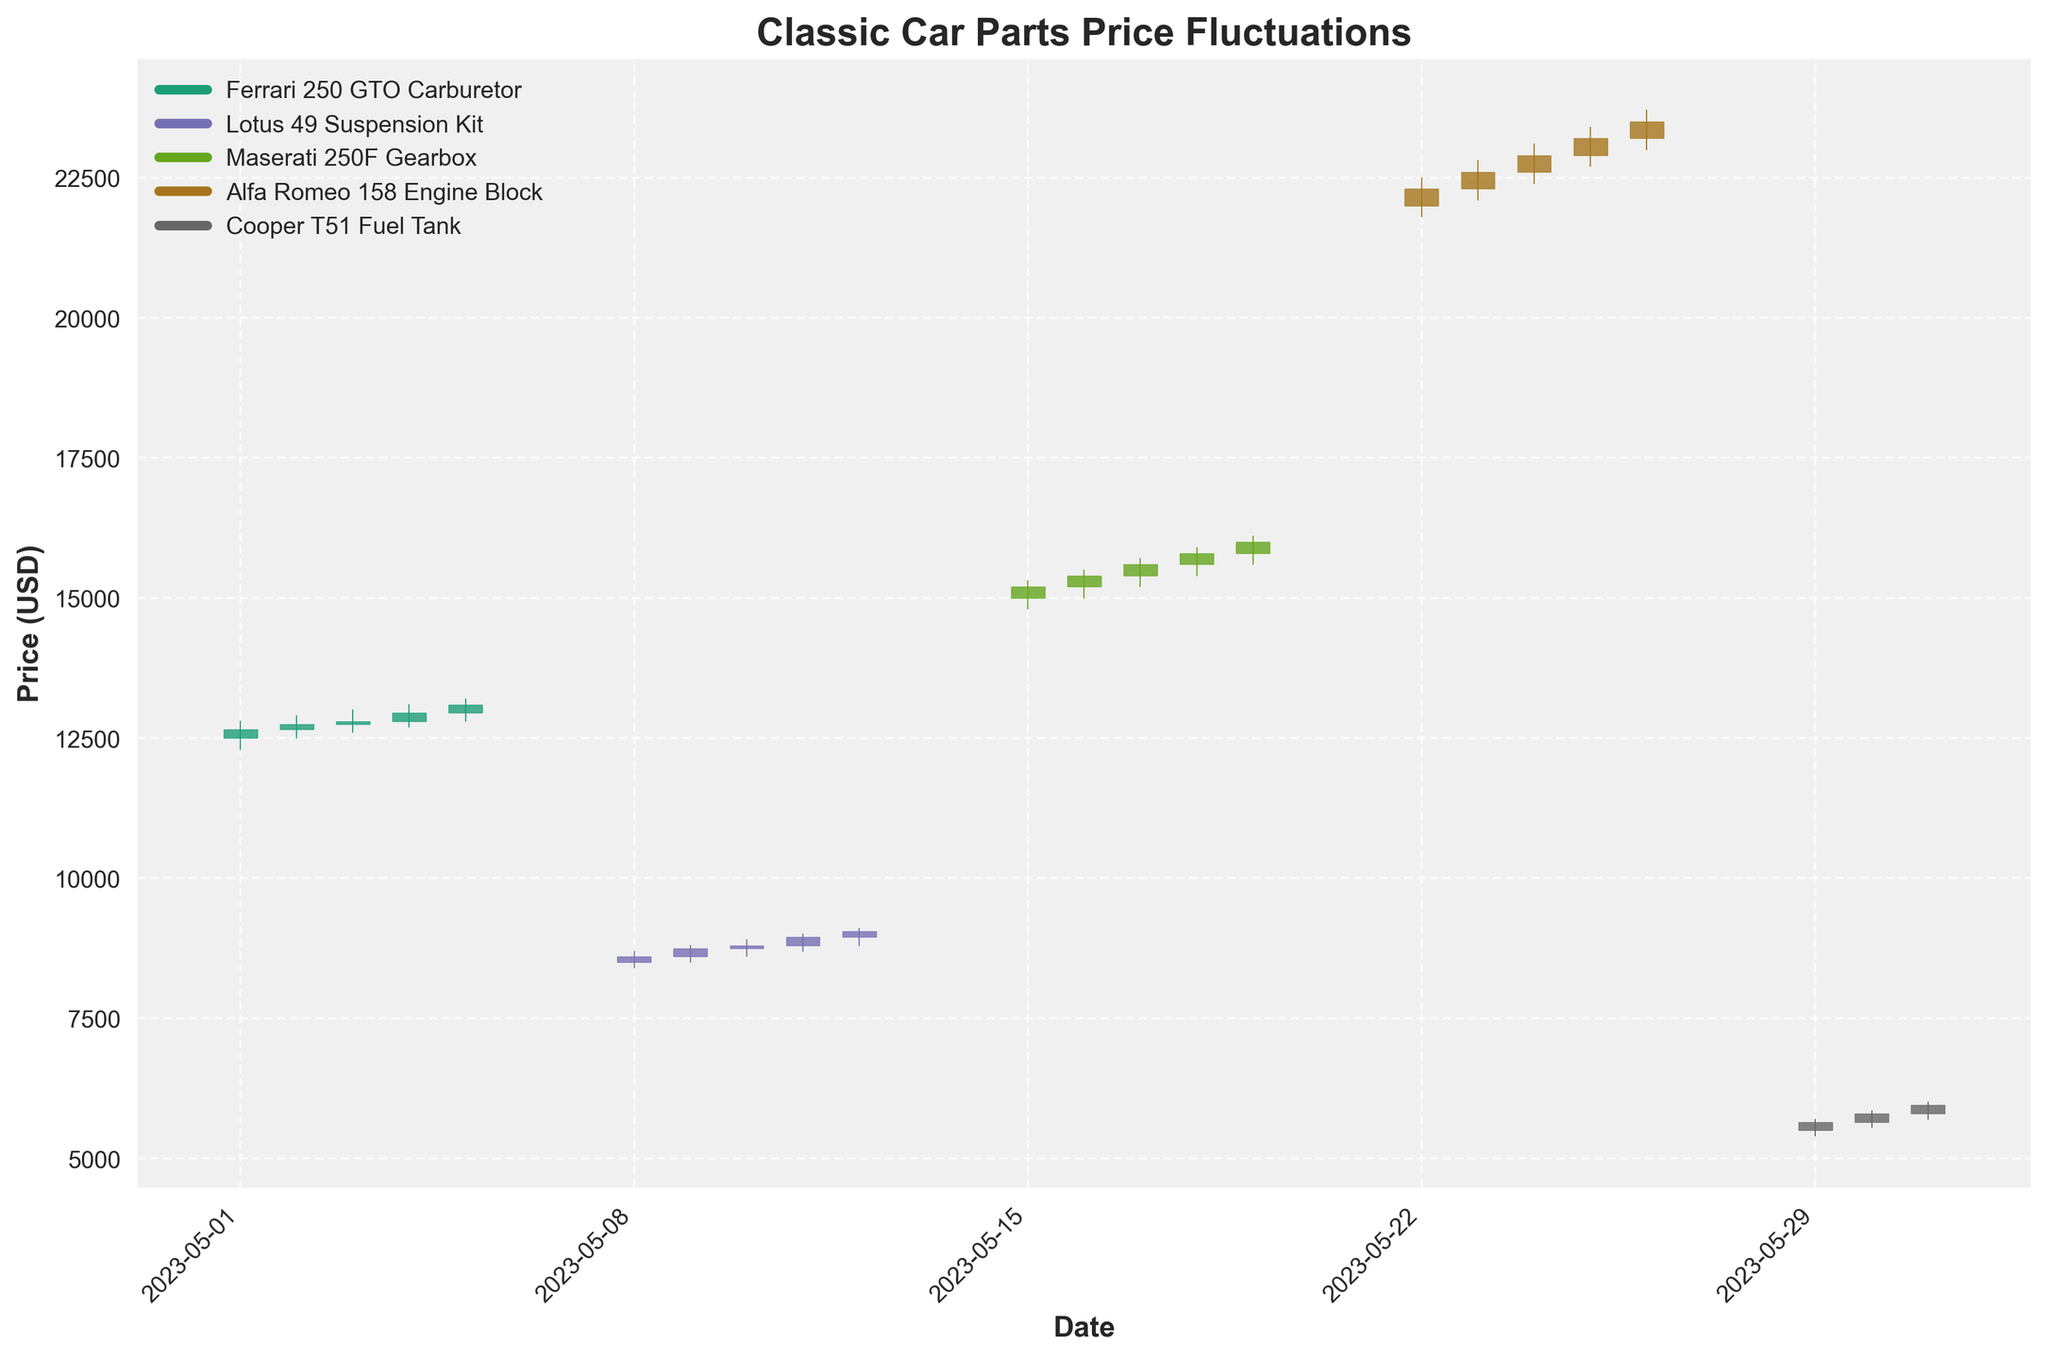What's the title of the plot? Look at the top section of the plot where the title is usually placed.
Answer: Classic Car Parts Price Fluctuations How many unique classic car parts are shown in the plot? Identify the number of different parts by checking distinct entries in the legend or the y-axis labels.
Answer: Five Which part had the highest price point within the month? Observe the highest point of the vertical lines (High values) for each part, and identify the maximum.
Answer: Alfa Romeo 158 Engine Block What is the opening price of Ferrari 250 GTO Carburetor on May 3rd? Locate the data point for May 3rd under Ferrari 250 GTO Carburetor and read the opening price.
Answer: 12750 For the Lotus 49 Suspension Kit, which day had the lowest closing price? Compare the closing prices throughout the days the Lotus 49 Suspension Kit is listed, and identify the lowest.
Answer: May 8 What's the average closing price for the Maserati 250F Gearbox across the month? Sum the closing prices of Maserati 250F Gearbox and divide by the number of data points for that part.
Answer: 15600 Which part experienced the greatest daily price range (difference between High and Low) on any single day? For each part and date, calculate the High minus Low and identify the maximum difference.
Answer: Alfa Romeo 158 Engine Block (on May 26) Did any part have a day where the closing price dropped below the opening price? Examine the bars for each part, date to see if the closing price is lower than the opening price.
Answer: Yes, multiple instances including May 10 for Lotus 49 Suspension Kit What is the trend of the Cooper T51 Fuel Tank prices over the observed days? Analyze the general direction of prices (Open, High, Low, Close) over the days for the Cooper T51 Fuel Tank.
Answer: Increasing trend Comparing May 5th and May 26th, which part had a higher closing price, Ferrari 250 GTO Carburetor or Alfa Romeo 158 Engine Block? Look at the closing prices on May 5 for Ferrari 250 GTO Carburetor and compare it with the closing price on May 26 for Alfa Romeo 158 Engine Block.
Answer: Alfa Romeo 158 Engine Block 